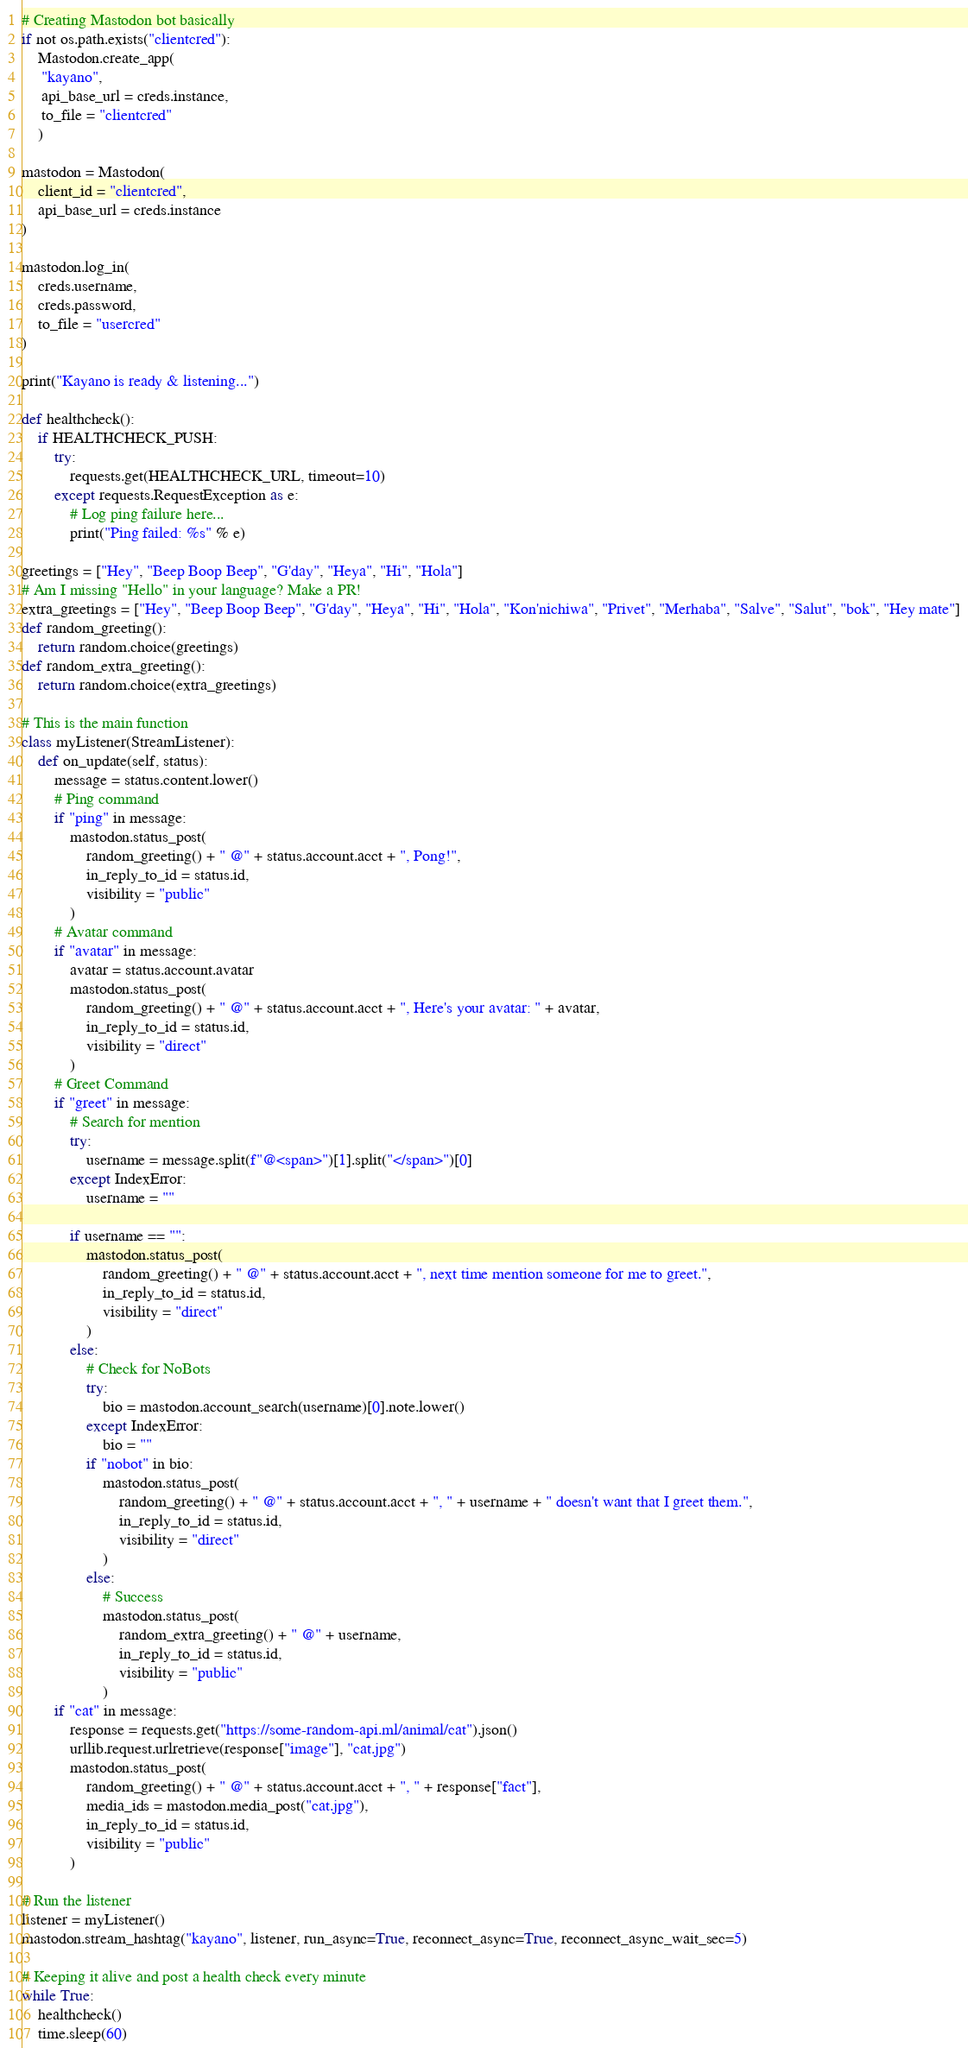<code> <loc_0><loc_0><loc_500><loc_500><_Python_># Creating Mastodon bot basically
if not os.path.exists("clientcred"):
    Mastodon.create_app(
     "kayano",
     api_base_url = creds.instance,
     to_file = "clientcred"
    )

mastodon = Mastodon(
    client_id = "clientcred",
    api_base_url = creds.instance
)

mastodon.log_in(
    creds.username,
    creds.password,
    to_file = "usercred"
)

print("Kayano is ready & listening...")

def healthcheck():
    if HEALTHCHECK_PUSH:
        try:
            requests.get(HEALTHCHECK_URL, timeout=10)
        except requests.RequestException as e:
            # Log ping failure here...
            print("Ping failed: %s" % e)

greetings = ["Hey", "Beep Boop Beep", "G'day", "Heya", "Hi", "Hola"]
# Am I missing "Hello" in your language? Make a PR!
extra_greetings = ["Hey", "Beep Boop Beep", "G'day", "Heya", "Hi", "Hola", "Kon'nichiwa", "Privet", "Merhaba", "Salve", "Salut", "bok", "Hey mate"]
def random_greeting():
    return random.choice(greetings)
def random_extra_greeting():
    return random.choice(extra_greetings)

# This is the main function
class myListener(StreamListener):
    def on_update(self, status):
        message = status.content.lower()
        # Ping command
        if "ping" in message:
            mastodon.status_post(
                random_greeting() + " @" + status.account.acct + ", Pong!",
                in_reply_to_id = status.id,
                visibility = "public"
            )
        # Avatar command
        if "avatar" in message:
            avatar = status.account.avatar
            mastodon.status_post(
                random_greeting() + " @" + status.account.acct + ", Here's your avatar: " + avatar,
                in_reply_to_id = status.id,
                visibility = "direct"
            )
        # Greet Command
        if "greet" in message:
            # Search for mention
            try:
                username = message.split(f"@<span>")[1].split("</span>")[0]
            except IndexError:
                username = ""

            if username == "":
                mastodon.status_post(
                    random_greeting() + " @" + status.account.acct + ", next time mention someone for me to greet.",
                    in_reply_to_id = status.id,
                    visibility = "direct"
                )
            else:
                # Check for NoBots
                try:
                    bio = mastodon.account_search(username)[0].note.lower()
                except IndexError:
                    bio = ""
                if "nobot" in bio:
                    mastodon.status_post(
                        random_greeting() + " @" + status.account.acct + ", " + username + " doesn't want that I greet them.",
                        in_reply_to_id = status.id,
                        visibility = "direct"
                    )
                else:
                    # Success
                    mastodon.status_post(
                        random_extra_greeting() + " @" + username,
                        in_reply_to_id = status.id,
                        visibility = "public"
                    )
        if "cat" in message:
            response = requests.get("https://some-random-api.ml/animal/cat").json()
            urllib.request.urlretrieve(response["image"], "cat.jpg")
            mastodon.status_post(
                random_greeting() + " @" + status.account.acct + ", " + response["fact"],
                media_ids = mastodon.media_post("cat.jpg"),
                in_reply_to_id = status.id,
                visibility = "public"
            )

# Run the listener 
listener = myListener()
mastodon.stream_hashtag("kayano", listener, run_async=True, reconnect_async=True, reconnect_async_wait_sec=5)

# Keeping it alive and post a health check every minute
while True:
    healthcheck()
    time.sleep(60)</code> 